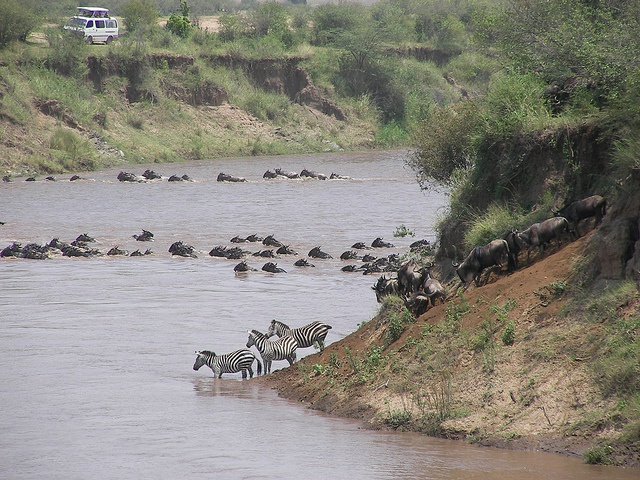Describe the objects in this image and their specific colors. I can see truck in gray, lightgray, and darkgray tones, zebra in gray, black, darkgray, and lightgray tones, zebra in gray, lightgray, darkgray, and black tones, and zebra in gray, black, darkgray, and lightgray tones in this image. 